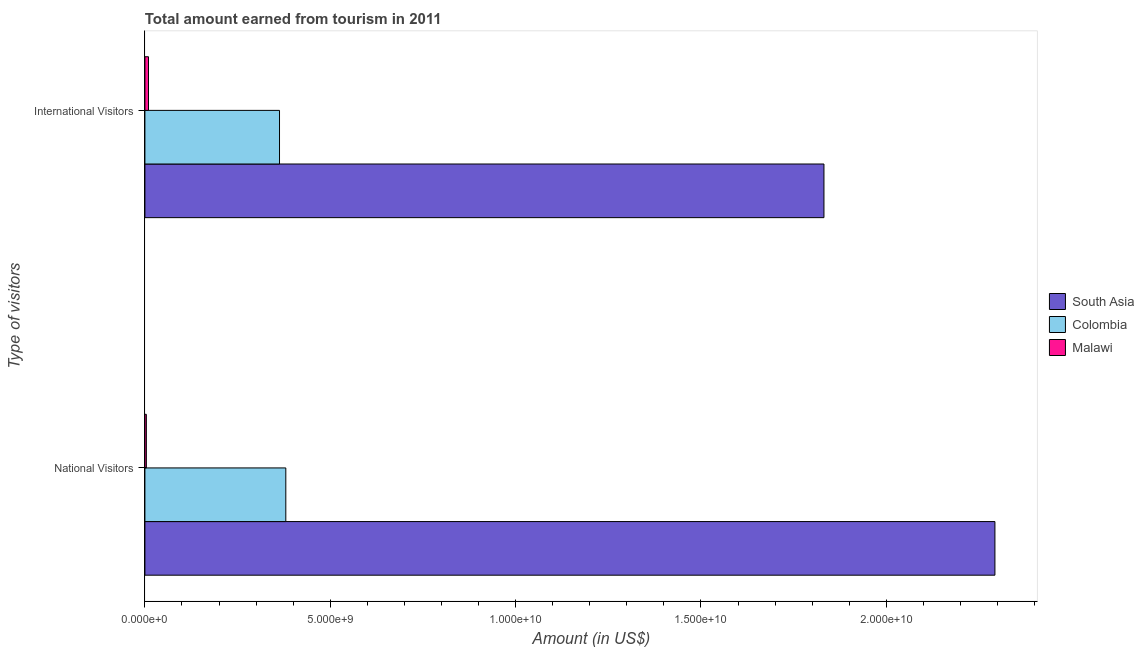How many different coloured bars are there?
Your answer should be compact. 3. How many bars are there on the 2nd tick from the top?
Make the answer very short. 3. What is the label of the 1st group of bars from the top?
Your answer should be compact. International Visitors. What is the amount earned from international visitors in Malawi?
Your answer should be compact. 9.70e+07. Across all countries, what is the maximum amount earned from international visitors?
Provide a succinct answer. 1.83e+1. Across all countries, what is the minimum amount earned from international visitors?
Provide a short and direct response. 9.70e+07. In which country was the amount earned from national visitors maximum?
Provide a succinct answer. South Asia. In which country was the amount earned from international visitors minimum?
Make the answer very short. Malawi. What is the total amount earned from international visitors in the graph?
Your response must be concise. 2.20e+1. What is the difference between the amount earned from national visitors in Colombia and that in Malawi?
Offer a very short reply. 3.76e+09. What is the difference between the amount earned from national visitors in Colombia and the amount earned from international visitors in South Asia?
Your response must be concise. -1.45e+1. What is the average amount earned from international visitors per country?
Offer a very short reply. 7.35e+09. What is the difference between the amount earned from international visitors and amount earned from national visitors in South Asia?
Your answer should be compact. -4.61e+09. What is the ratio of the amount earned from international visitors in Colombia to that in South Asia?
Make the answer very short. 0.2. In how many countries, is the amount earned from international visitors greater than the average amount earned from international visitors taken over all countries?
Your answer should be very brief. 1. What does the 3rd bar from the top in International Visitors represents?
Provide a short and direct response. South Asia. Are all the bars in the graph horizontal?
Your answer should be very brief. Yes. Are the values on the major ticks of X-axis written in scientific E-notation?
Ensure brevity in your answer.  Yes. Does the graph contain grids?
Your answer should be very brief. No. How many legend labels are there?
Make the answer very short. 3. How are the legend labels stacked?
Your answer should be very brief. Vertical. What is the title of the graph?
Your response must be concise. Total amount earned from tourism in 2011. Does "Bahrain" appear as one of the legend labels in the graph?
Offer a very short reply. No. What is the label or title of the X-axis?
Your answer should be very brief. Amount (in US$). What is the label or title of the Y-axis?
Ensure brevity in your answer.  Type of visitors. What is the Amount (in US$) in South Asia in National Visitors?
Your answer should be compact. 2.29e+1. What is the Amount (in US$) in Colombia in National Visitors?
Offer a terse response. 3.80e+09. What is the Amount (in US$) of Malawi in National Visitors?
Your answer should be compact. 3.90e+07. What is the Amount (in US$) of South Asia in International Visitors?
Your answer should be very brief. 1.83e+1. What is the Amount (in US$) of Colombia in International Visitors?
Keep it short and to the point. 3.63e+09. What is the Amount (in US$) of Malawi in International Visitors?
Your answer should be compact. 9.70e+07. Across all Type of visitors, what is the maximum Amount (in US$) in South Asia?
Provide a succinct answer. 2.29e+1. Across all Type of visitors, what is the maximum Amount (in US$) in Colombia?
Make the answer very short. 3.80e+09. Across all Type of visitors, what is the maximum Amount (in US$) of Malawi?
Your response must be concise. 9.70e+07. Across all Type of visitors, what is the minimum Amount (in US$) of South Asia?
Ensure brevity in your answer.  1.83e+1. Across all Type of visitors, what is the minimum Amount (in US$) in Colombia?
Provide a short and direct response. 3.63e+09. Across all Type of visitors, what is the minimum Amount (in US$) in Malawi?
Your response must be concise. 3.90e+07. What is the total Amount (in US$) in South Asia in the graph?
Make the answer very short. 4.12e+1. What is the total Amount (in US$) of Colombia in the graph?
Your response must be concise. 7.43e+09. What is the total Amount (in US$) of Malawi in the graph?
Ensure brevity in your answer.  1.36e+08. What is the difference between the Amount (in US$) in South Asia in National Visitors and that in International Visitors?
Offer a terse response. 4.61e+09. What is the difference between the Amount (in US$) of Colombia in National Visitors and that in International Visitors?
Your response must be concise. 1.70e+08. What is the difference between the Amount (in US$) in Malawi in National Visitors and that in International Visitors?
Your response must be concise. -5.80e+07. What is the difference between the Amount (in US$) in South Asia in National Visitors and the Amount (in US$) in Colombia in International Visitors?
Provide a succinct answer. 1.93e+1. What is the difference between the Amount (in US$) in South Asia in National Visitors and the Amount (in US$) in Malawi in International Visitors?
Your answer should be compact. 2.28e+1. What is the difference between the Amount (in US$) of Colombia in National Visitors and the Amount (in US$) of Malawi in International Visitors?
Give a very brief answer. 3.70e+09. What is the average Amount (in US$) in South Asia per Type of visitors?
Your answer should be very brief. 2.06e+1. What is the average Amount (in US$) of Colombia per Type of visitors?
Make the answer very short. 3.72e+09. What is the average Amount (in US$) in Malawi per Type of visitors?
Make the answer very short. 6.80e+07. What is the difference between the Amount (in US$) of South Asia and Amount (in US$) of Colombia in National Visitors?
Offer a terse response. 1.91e+1. What is the difference between the Amount (in US$) of South Asia and Amount (in US$) of Malawi in National Visitors?
Your answer should be compact. 2.29e+1. What is the difference between the Amount (in US$) in Colombia and Amount (in US$) in Malawi in National Visitors?
Provide a succinct answer. 3.76e+09. What is the difference between the Amount (in US$) in South Asia and Amount (in US$) in Colombia in International Visitors?
Make the answer very short. 1.47e+1. What is the difference between the Amount (in US$) in South Asia and Amount (in US$) in Malawi in International Visitors?
Provide a succinct answer. 1.82e+1. What is the difference between the Amount (in US$) of Colombia and Amount (in US$) of Malawi in International Visitors?
Your answer should be compact. 3.53e+09. What is the ratio of the Amount (in US$) in South Asia in National Visitors to that in International Visitors?
Offer a terse response. 1.25. What is the ratio of the Amount (in US$) of Colombia in National Visitors to that in International Visitors?
Provide a succinct answer. 1.05. What is the ratio of the Amount (in US$) of Malawi in National Visitors to that in International Visitors?
Your answer should be compact. 0.4. What is the difference between the highest and the second highest Amount (in US$) in South Asia?
Your answer should be compact. 4.61e+09. What is the difference between the highest and the second highest Amount (in US$) in Colombia?
Provide a succinct answer. 1.70e+08. What is the difference between the highest and the second highest Amount (in US$) of Malawi?
Offer a terse response. 5.80e+07. What is the difference between the highest and the lowest Amount (in US$) of South Asia?
Keep it short and to the point. 4.61e+09. What is the difference between the highest and the lowest Amount (in US$) in Colombia?
Your response must be concise. 1.70e+08. What is the difference between the highest and the lowest Amount (in US$) in Malawi?
Your response must be concise. 5.80e+07. 